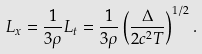Convert formula to latex. <formula><loc_0><loc_0><loc_500><loc_500>L _ { x } = \frac { 1 } { 3 \rho } L _ { t } = \frac { 1 } { 3 \rho } \left ( \frac { \Delta } { 2 c ^ { 2 } T } \right ) ^ { 1 / 2 } .</formula> 